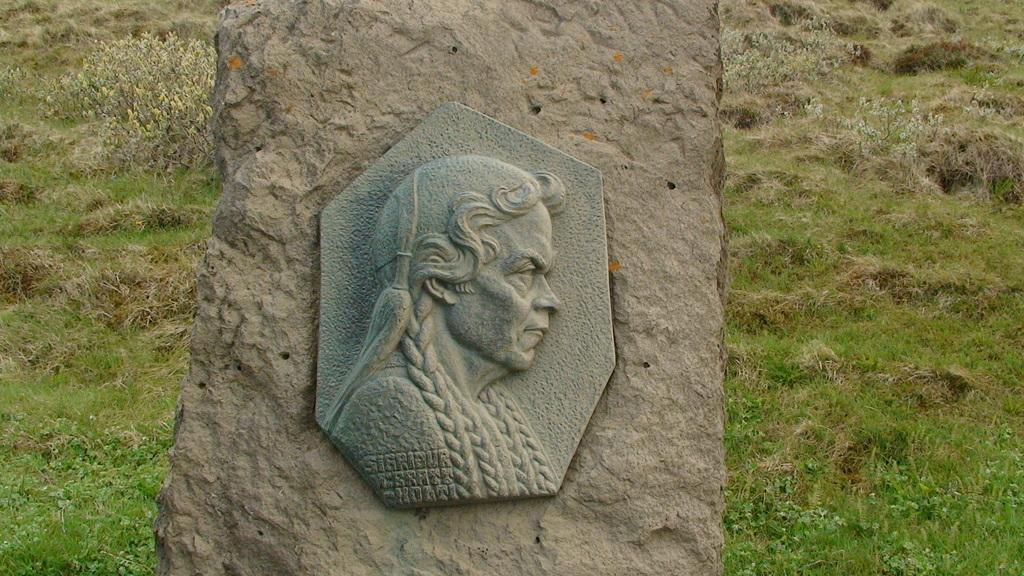How would you summarize this image in a sentence or two? In this image in the center there is a pillar, and on the pillar there is a sculpture of a person and in the background there is grass. 